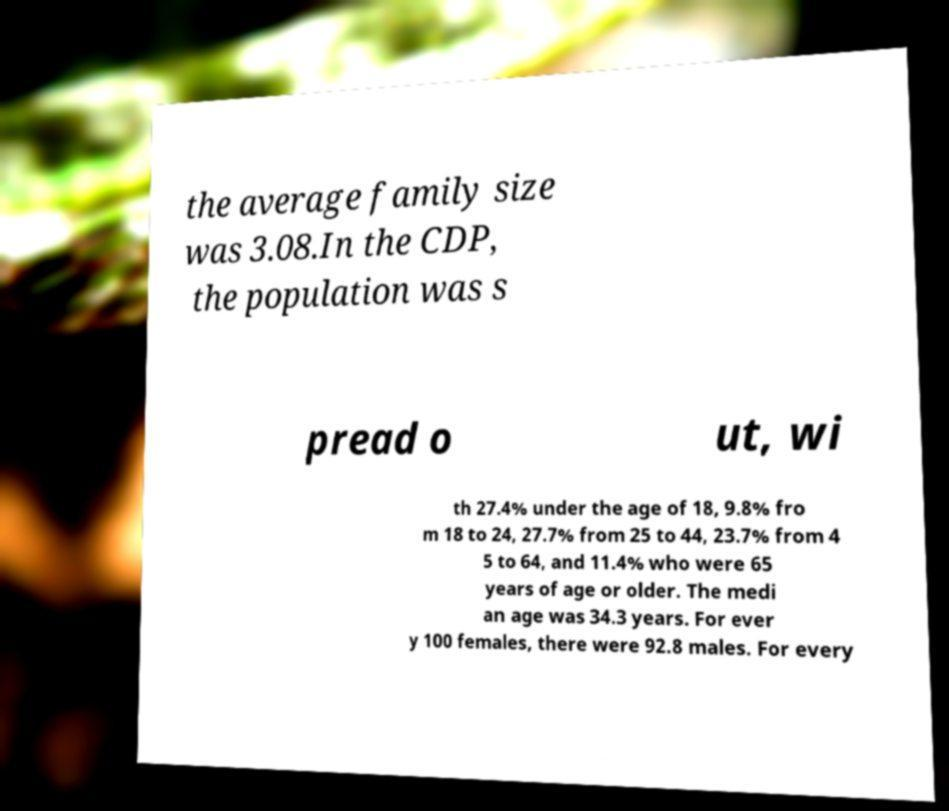Can you accurately transcribe the text from the provided image for me? the average family size was 3.08.In the CDP, the population was s pread o ut, wi th 27.4% under the age of 18, 9.8% fro m 18 to 24, 27.7% from 25 to 44, 23.7% from 4 5 to 64, and 11.4% who were 65 years of age or older. The medi an age was 34.3 years. For ever y 100 females, there were 92.8 males. For every 